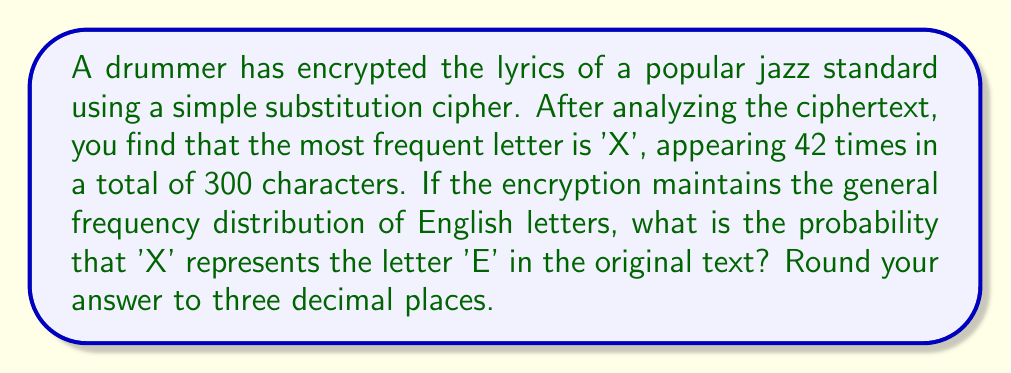Can you answer this question? To solve this problem, we'll follow these steps:

1. Recall that in standard English text, the letter 'E' is the most frequent, occurring approximately 12.7% of the time.

2. Calculate the frequency of 'X' in the ciphertext:
   $$f_X = \frac{\text{Number of X occurrences}}{\text{Total characters}} = \frac{42}{300} = 0.14 = 14\%$$

3. Compare this to the expected frequency of 'E' (12.7%). The observed frequency is close to, but slightly higher than, the expected frequency.

4. To calculate the probability, we can use a simple ratio:
   $$P(\text{X = E}) = \frac{\text{Expected frequency of E}}{\text{Observed frequency of X}} = \frac{0.127}{0.14}$$

5. Compute the final result:
   $$P(\text{X = E}) = \frac{0.127}{0.14} \approx 0.9071428571$$

6. Round to three decimal places: 0.907

This probability suggests that it's quite likely that 'X' represents 'E' in the original text, given how close the observed frequency is to the expected frequency of 'E' in English.
Answer: 0.907 